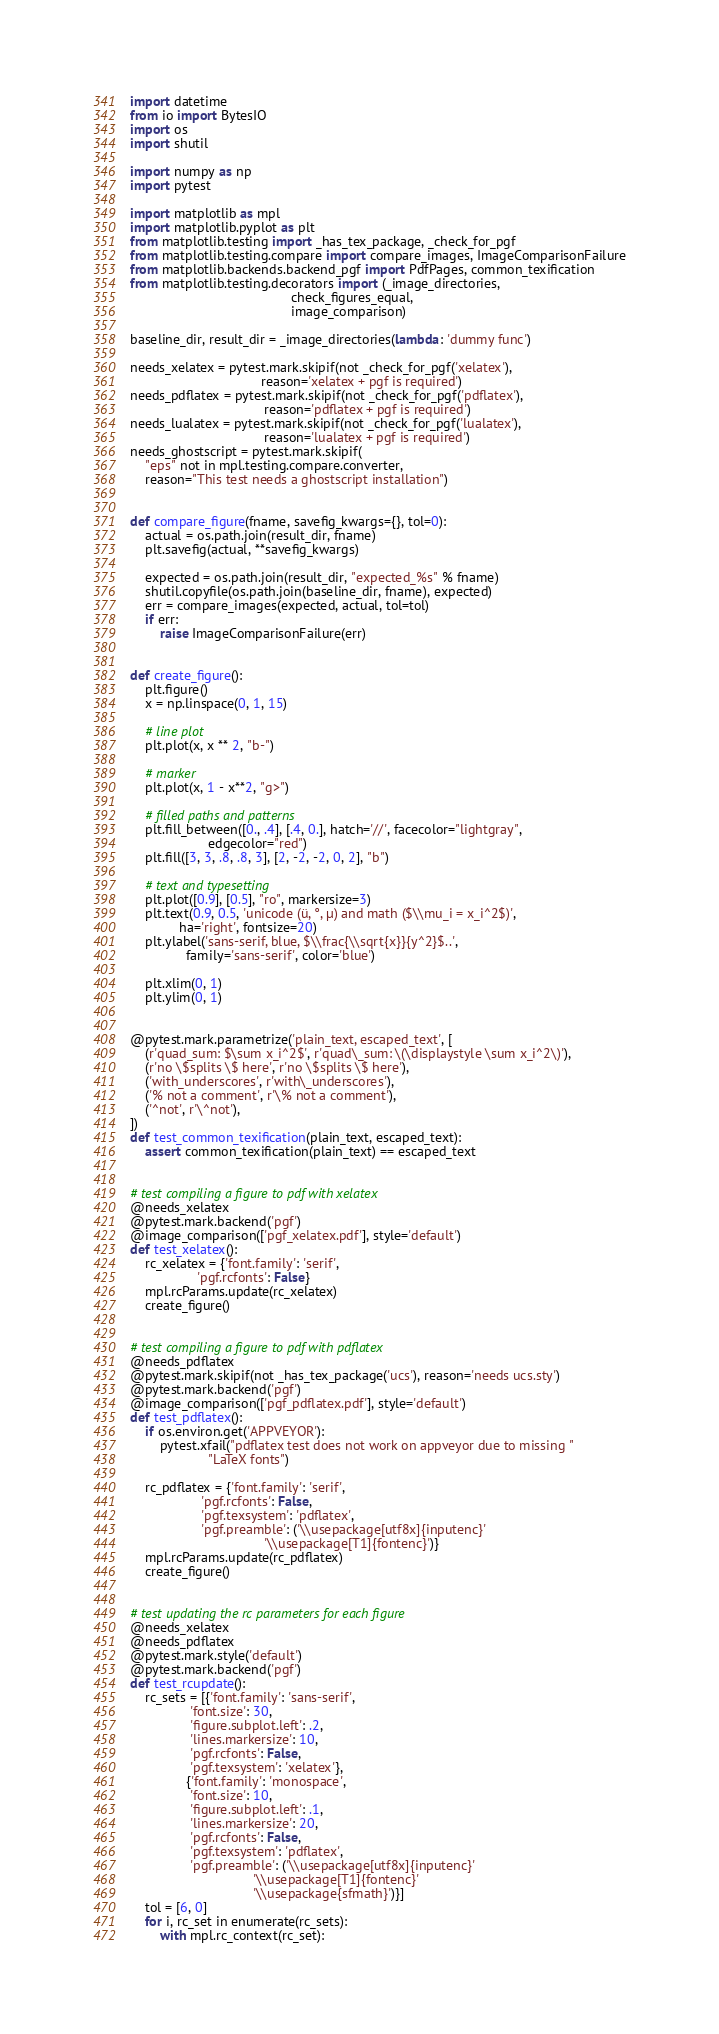Convert code to text. <code><loc_0><loc_0><loc_500><loc_500><_Python_>import datetime
from io import BytesIO
import os
import shutil

import numpy as np
import pytest

import matplotlib as mpl
import matplotlib.pyplot as plt
from matplotlib.testing import _has_tex_package, _check_for_pgf
from matplotlib.testing.compare import compare_images, ImageComparisonFailure
from matplotlib.backends.backend_pgf import PdfPages, common_texification
from matplotlib.testing.decorators import (_image_directories,
                                           check_figures_equal,
                                           image_comparison)

baseline_dir, result_dir = _image_directories(lambda: 'dummy func')

needs_xelatex = pytest.mark.skipif(not _check_for_pgf('xelatex'),
                                   reason='xelatex + pgf is required')
needs_pdflatex = pytest.mark.skipif(not _check_for_pgf('pdflatex'),
                                    reason='pdflatex + pgf is required')
needs_lualatex = pytest.mark.skipif(not _check_for_pgf('lualatex'),
                                    reason='lualatex + pgf is required')
needs_ghostscript = pytest.mark.skipif(
    "eps" not in mpl.testing.compare.converter,
    reason="This test needs a ghostscript installation")


def compare_figure(fname, savefig_kwargs={}, tol=0):
    actual = os.path.join(result_dir, fname)
    plt.savefig(actual, **savefig_kwargs)

    expected = os.path.join(result_dir, "expected_%s" % fname)
    shutil.copyfile(os.path.join(baseline_dir, fname), expected)
    err = compare_images(expected, actual, tol=tol)
    if err:
        raise ImageComparisonFailure(err)


def create_figure():
    plt.figure()
    x = np.linspace(0, 1, 15)

    # line plot
    plt.plot(x, x ** 2, "b-")

    # marker
    plt.plot(x, 1 - x**2, "g>")

    # filled paths and patterns
    plt.fill_between([0., .4], [.4, 0.], hatch='//', facecolor="lightgray",
                     edgecolor="red")
    plt.fill([3, 3, .8, .8, 3], [2, -2, -2, 0, 2], "b")

    # text and typesetting
    plt.plot([0.9], [0.5], "ro", markersize=3)
    plt.text(0.9, 0.5, 'unicode (ü, °, µ) and math ($\\mu_i = x_i^2$)',
             ha='right', fontsize=20)
    plt.ylabel('sans-serif, blue, $\\frac{\\sqrt{x}}{y^2}$..',
               family='sans-serif', color='blue')

    plt.xlim(0, 1)
    plt.ylim(0, 1)


@pytest.mark.parametrize('plain_text, escaped_text', [
    (r'quad_sum: $\sum x_i^2$', r'quad\_sum: \(\displaystyle \sum x_i^2\)'),
    (r'no \$splits \$ here', r'no \$splits \$ here'),
    ('with_underscores', r'with\_underscores'),
    ('% not a comment', r'\% not a comment'),
    ('^not', r'\^not'),
])
def test_common_texification(plain_text, escaped_text):
    assert common_texification(plain_text) == escaped_text


# test compiling a figure to pdf with xelatex
@needs_xelatex
@pytest.mark.backend('pgf')
@image_comparison(['pgf_xelatex.pdf'], style='default')
def test_xelatex():
    rc_xelatex = {'font.family': 'serif',
                  'pgf.rcfonts': False}
    mpl.rcParams.update(rc_xelatex)
    create_figure()


# test compiling a figure to pdf with pdflatex
@needs_pdflatex
@pytest.mark.skipif(not _has_tex_package('ucs'), reason='needs ucs.sty')
@pytest.mark.backend('pgf')
@image_comparison(['pgf_pdflatex.pdf'], style='default')
def test_pdflatex():
    if os.environ.get('APPVEYOR'):
        pytest.xfail("pdflatex test does not work on appveyor due to missing "
                     "LaTeX fonts")

    rc_pdflatex = {'font.family': 'serif',
                   'pgf.rcfonts': False,
                   'pgf.texsystem': 'pdflatex',
                   'pgf.preamble': ('\\usepackage[utf8x]{inputenc}'
                                    '\\usepackage[T1]{fontenc}')}
    mpl.rcParams.update(rc_pdflatex)
    create_figure()


# test updating the rc parameters for each figure
@needs_xelatex
@needs_pdflatex
@pytest.mark.style('default')
@pytest.mark.backend('pgf')
def test_rcupdate():
    rc_sets = [{'font.family': 'sans-serif',
                'font.size': 30,
                'figure.subplot.left': .2,
                'lines.markersize': 10,
                'pgf.rcfonts': False,
                'pgf.texsystem': 'xelatex'},
               {'font.family': 'monospace',
                'font.size': 10,
                'figure.subplot.left': .1,
                'lines.markersize': 20,
                'pgf.rcfonts': False,
                'pgf.texsystem': 'pdflatex',
                'pgf.preamble': ('\\usepackage[utf8x]{inputenc}'
                                 '\\usepackage[T1]{fontenc}'
                                 '\\usepackage{sfmath}')}]
    tol = [6, 0]
    for i, rc_set in enumerate(rc_sets):
        with mpl.rc_context(rc_set):</code> 